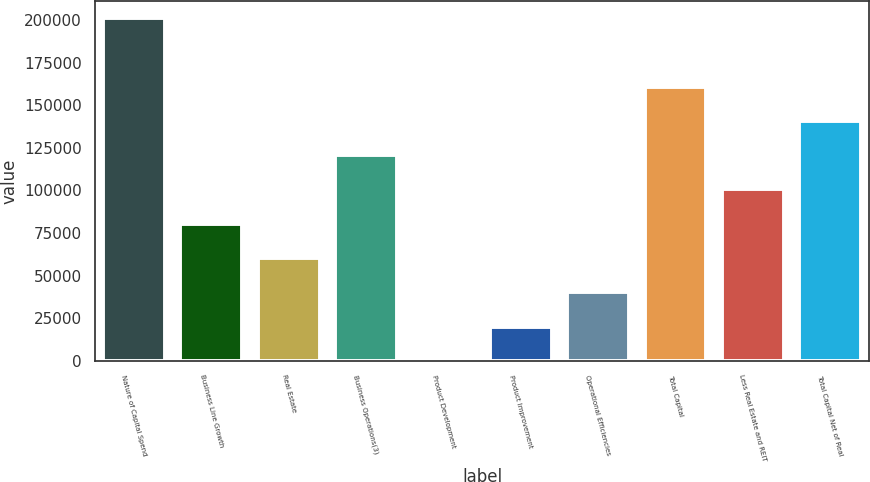Convert chart. <chart><loc_0><loc_0><loc_500><loc_500><bar_chart><fcel>Nature of Capital Spend<fcel>Business Line Growth<fcel>Real Estate<fcel>Business Operations(3)<fcel>Product Development<fcel>Product Improvement<fcel>Operational Efficiencies<fcel>Total Capital<fcel>Less Real Estate and REIT<fcel>Total Capital Net of Real<nl><fcel>201212<fcel>80487.2<fcel>60366.4<fcel>120729<fcel>4<fcel>20124.8<fcel>40245.6<fcel>160970<fcel>100608<fcel>140850<nl></chart> 